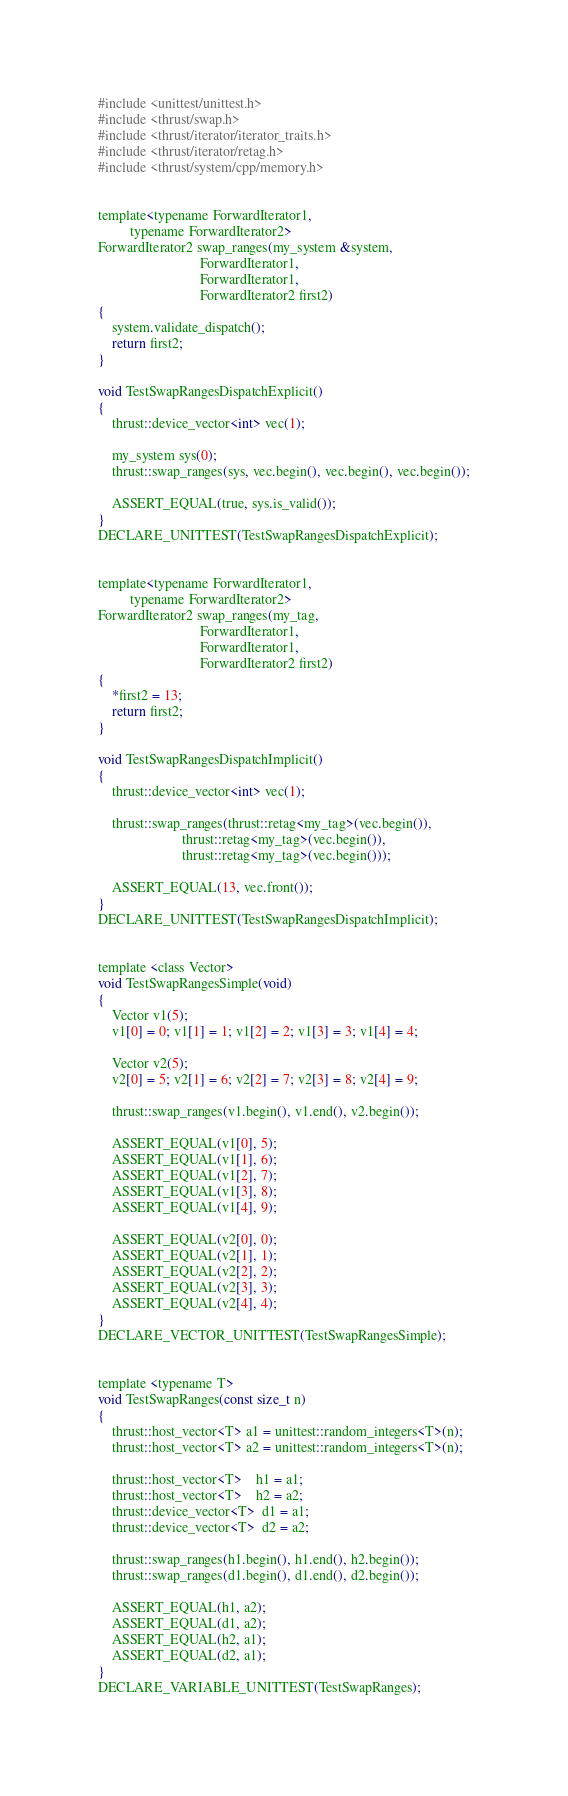Convert code to text. <code><loc_0><loc_0><loc_500><loc_500><_Cuda_>#include <unittest/unittest.h>
#include <thrust/swap.h>
#include <thrust/iterator/iterator_traits.h>
#include <thrust/iterator/retag.h>
#include <thrust/system/cpp/memory.h>


template<typename ForwardIterator1,
         typename ForwardIterator2>
ForwardIterator2 swap_ranges(my_system &system,
                             ForwardIterator1,
                             ForwardIterator1,
                             ForwardIterator2 first2)
{
    system.validate_dispatch();
    return first2;
}

void TestSwapRangesDispatchExplicit()
{
    thrust::device_vector<int> vec(1);

    my_system sys(0);
    thrust::swap_ranges(sys, vec.begin(), vec.begin(), vec.begin());

    ASSERT_EQUAL(true, sys.is_valid());
}
DECLARE_UNITTEST(TestSwapRangesDispatchExplicit);


template<typename ForwardIterator1,
         typename ForwardIterator2>
ForwardIterator2 swap_ranges(my_tag,
                             ForwardIterator1,
                             ForwardIterator1,
                             ForwardIterator2 first2)
{
    *first2 = 13;
    return first2;
}

void TestSwapRangesDispatchImplicit()
{
    thrust::device_vector<int> vec(1);

    thrust::swap_ranges(thrust::retag<my_tag>(vec.begin()),
                        thrust::retag<my_tag>(vec.begin()),
                        thrust::retag<my_tag>(vec.begin()));

    ASSERT_EQUAL(13, vec.front());
}
DECLARE_UNITTEST(TestSwapRangesDispatchImplicit);


template <class Vector>
void TestSwapRangesSimple(void)
{
    Vector v1(5);
    v1[0] = 0; v1[1] = 1; v1[2] = 2; v1[3] = 3; v1[4] = 4;

    Vector v2(5);
    v2[0] = 5; v2[1] = 6; v2[2] = 7; v2[3] = 8; v2[4] = 9;

    thrust::swap_ranges(v1.begin(), v1.end(), v2.begin());

    ASSERT_EQUAL(v1[0], 5);
    ASSERT_EQUAL(v1[1], 6);
    ASSERT_EQUAL(v1[2], 7);
    ASSERT_EQUAL(v1[3], 8);
    ASSERT_EQUAL(v1[4], 9);

    ASSERT_EQUAL(v2[0], 0);
    ASSERT_EQUAL(v2[1], 1);
    ASSERT_EQUAL(v2[2], 2);
    ASSERT_EQUAL(v2[3], 3);
    ASSERT_EQUAL(v2[4], 4);
}
DECLARE_VECTOR_UNITTEST(TestSwapRangesSimple);


template <typename T>
void TestSwapRanges(const size_t n)
{
    thrust::host_vector<T> a1 = unittest::random_integers<T>(n);
    thrust::host_vector<T> a2 = unittest::random_integers<T>(n);

    thrust::host_vector<T>    h1 = a1;
    thrust::host_vector<T>    h2 = a2;
    thrust::device_vector<T>  d1 = a1;
    thrust::device_vector<T>  d2 = a2;

    thrust::swap_ranges(h1.begin(), h1.end(), h2.begin());
    thrust::swap_ranges(d1.begin(), d1.end(), d2.begin());

    ASSERT_EQUAL(h1, a2);
    ASSERT_EQUAL(d1, a2);
    ASSERT_EQUAL(h2, a1);
    ASSERT_EQUAL(d2, a1);
}
DECLARE_VARIABLE_UNITTEST(TestSwapRanges);
</code> 